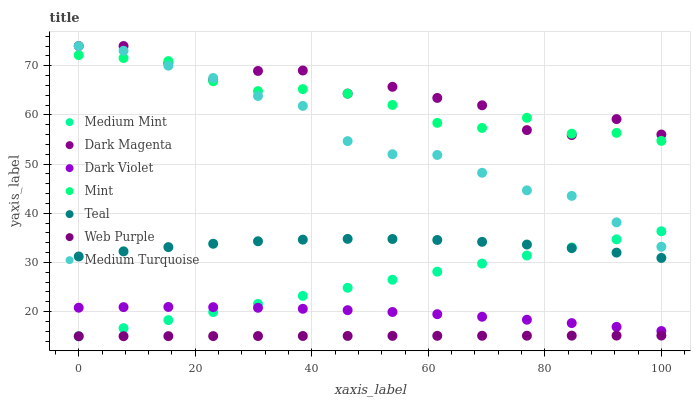Does Web Purple have the minimum area under the curve?
Answer yes or no. Yes. Does Dark Magenta have the maximum area under the curve?
Answer yes or no. Yes. Does Medium Turquoise have the minimum area under the curve?
Answer yes or no. No. Does Medium Turquoise have the maximum area under the curve?
Answer yes or no. No. Is Web Purple the smoothest?
Answer yes or no. Yes. Is Dark Magenta the roughest?
Answer yes or no. Yes. Is Medium Turquoise the smoothest?
Answer yes or no. No. Is Medium Turquoise the roughest?
Answer yes or no. No. Does Medium Mint have the lowest value?
Answer yes or no. Yes. Does Medium Turquoise have the lowest value?
Answer yes or no. No. Does Dark Magenta have the highest value?
Answer yes or no. Yes. Does Dark Violet have the highest value?
Answer yes or no. No. Is Dark Violet less than Medium Turquoise?
Answer yes or no. Yes. Is Mint greater than Web Purple?
Answer yes or no. Yes. Does Medium Mint intersect Medium Turquoise?
Answer yes or no. Yes. Is Medium Mint less than Medium Turquoise?
Answer yes or no. No. Is Medium Mint greater than Medium Turquoise?
Answer yes or no. No. Does Dark Violet intersect Medium Turquoise?
Answer yes or no. No. 